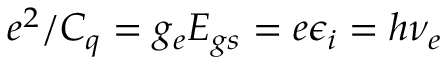Convert formula to latex. <formula><loc_0><loc_0><loc_500><loc_500>e ^ { 2 } / C _ { q } = g _ { e } E _ { g s } = e \epsilon _ { i } = h \nu _ { e }</formula> 